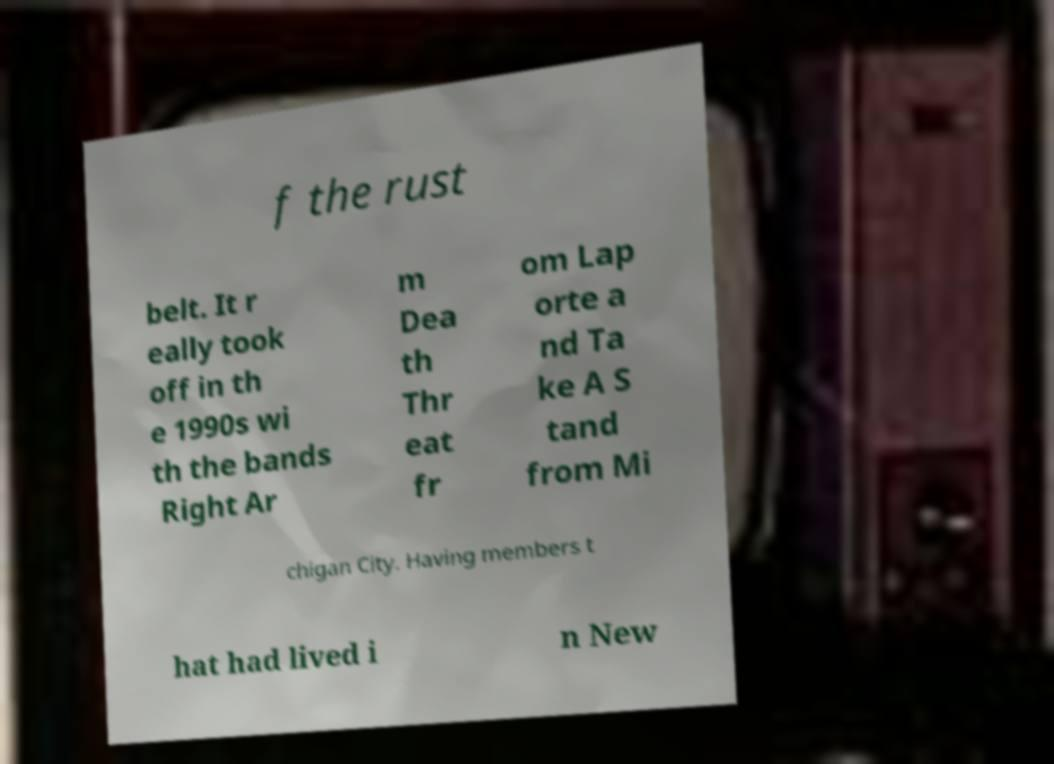Can you accurately transcribe the text from the provided image for me? f the rust belt. It r eally took off in th e 1990s wi th the bands Right Ar m Dea th Thr eat fr om Lap orte a nd Ta ke A S tand from Mi chigan City. Having members t hat had lived i n New 